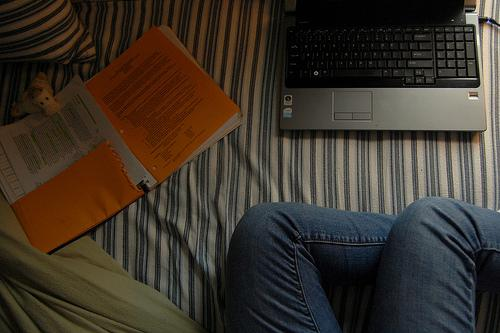Question: what color are the person's pants?
Choices:
A. Green.
B. Black.
C. Brown.
D. Blue.
Answer with the letter. Answer: D Question: who is on the bed?
Choices:
A. A scary clown.
B. The person.
C. A baby.
D. The referee.
Answer with the letter. Answer: B Question: what color is the folder?
Choices:
A. Yellow.
B. White.
C. Blue.
D. Orange.
Answer with the letter. Answer: D 